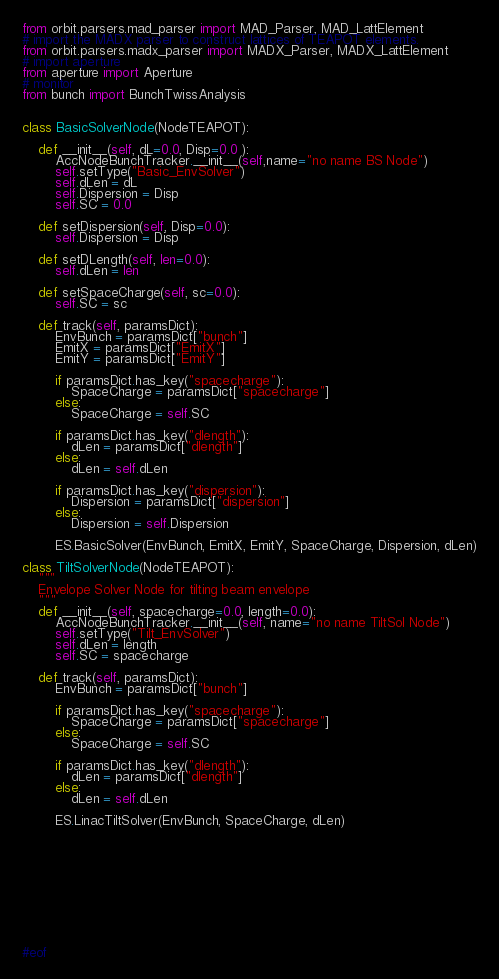<code> <loc_0><loc_0><loc_500><loc_500><_Python_>from orbit.parsers.mad_parser import MAD_Parser, MAD_LattElement
# import the MADX parser to construct lattices of TEAPOT elements.
from orbit.parsers.madx_parser import MADX_Parser, MADX_LattElement
# import aperture
from aperture import Aperture
# monitor
from bunch import BunchTwissAnalysis


class BasicSolverNode(NodeTEAPOT):

    def __init__(self, dL=0.0, Disp=0.0 ):
        AccNodeBunchTracker.__init__(self,name="no name BS Node")
        self.setType("Basic_EnvSolver")
        self.dLen = dL
        self.Dispersion = Disp
        self.SC = 0.0

    def setDispersion(self, Disp=0.0):
        self.Dispersion = Disp

    def setDLength(self, len=0.0):
        self.dLen = len

    def setSpaceCharge(self, sc=0.0):
        self.SC = sc

    def track(self, paramsDict):
        EnvBunch = paramsDict["bunch"]
        EmitX = paramsDict["EmitX"]
        EmitY = paramsDict["EmitY"]

        if paramsDict.has_key("spacecharge"):
            SpaceCharge = paramsDict["spacecharge"]
        else:
            SpaceCharge = self.SC

        if paramsDict.has_key("dlength"):
            dLen = paramsDict["dlength"]
        else:
            dLen = self.dLen

        if paramsDict.has_key("dispersion"):
            Dispersion = paramsDict["dispersion"]
        else:
            Dispersion = self.Dispersion

        ES.BasicSolver(EnvBunch, EmitX, EmitY, SpaceCharge, Dispersion, dLen)

class TiltSolverNode(NodeTEAPOT):
    """
    Envelope Solver Node for tilting beam envelope
    """
    def __init__(self, spacecharge=0.0, length=0.0):
        AccNodeBunchTracker.__init__(self, name="no name TiltSol Node")
        self.setType("Tilt_EnvSolver")
        self.dLen = length
        self.SC = spacecharge

    def track(self, paramsDict):
        EnvBunch = paramsDict["bunch"]

        if paramsDict.has_key("spacecharge"):
            SpaceCharge = paramsDict["spacecharge"]
        else:
            SpaceCharge = self.SC

        if paramsDict.has_key("dlength"):
            dLen = paramsDict["dlength"]
        else:
            dLen = self.dLen

        ES.LinacTiltSolver(EnvBunch, SpaceCharge, dLen)











#eof
</code> 